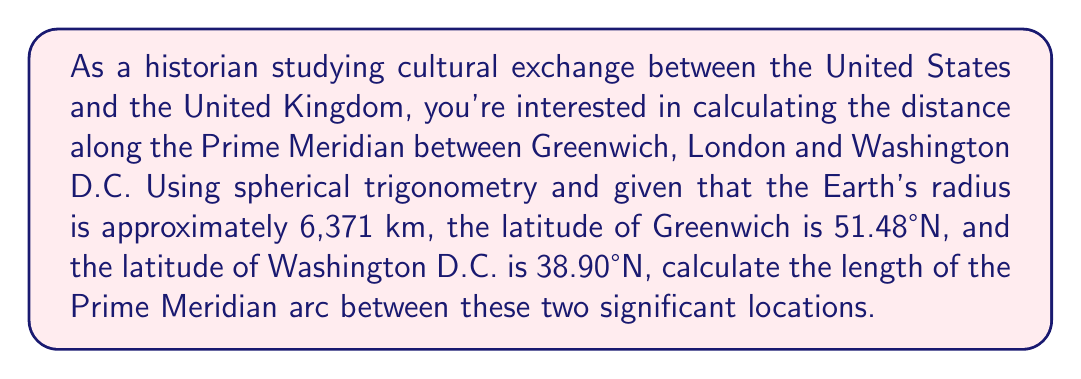What is the answer to this math problem? To solve this problem, we'll use the spherical law of cosines formula for great circle distance. The steps are as follows:

1. Convert the latitudes to radians:
   Greenwich: $\phi_1 = 51.48° \times \frac{\pi}{180°} = 0.8983$ radians
   Washington D.C.: $\phi_2 = 38.90° \times \frac{\pi}{180°} = 0.6789$ radians

2. The longitude difference is 0° since both locations are on the Prime Meridian.

3. Apply the spherical law of cosines formula:
   $$\cos(c) = \sin(\phi_1)\sin(\phi_2) + \cos(\phi_1)\cos(\phi_2)\cos(\Delta\lambda)$$
   
   Where $c$ is the central angle, $\phi_1$ and $\phi_2$ are the latitudes, and $\Delta\lambda$ is the longitude difference.

4. Substitute the values:
   $$\cos(c) = \sin(0.8983)\sin(0.6789) + \cos(0.8983)\cos(0.6789)\cos(0)$$
   $$\cos(c) = 0.7820 \times 0.6284 + 0.6233 \times 0.7778 \times 1$$
   $$\cos(c) = 0.4914 + 0.4849 = 0.9763$$

5. Solve for $c$:
   $$c = \arccos(0.9763) = 0.2185 \text{ radians}$$

6. Calculate the arc length:
   $$s = R \times c$$
   Where $R$ is the Earth's radius (6,371 km)
   $$s = 6371 \times 0.2185 = 1392.06 \text{ km}$$

Therefore, the length of the Prime Meridian arc between Greenwich, London and Washington D.C. is approximately 1,392.06 km.
Answer: 1,392.06 km 